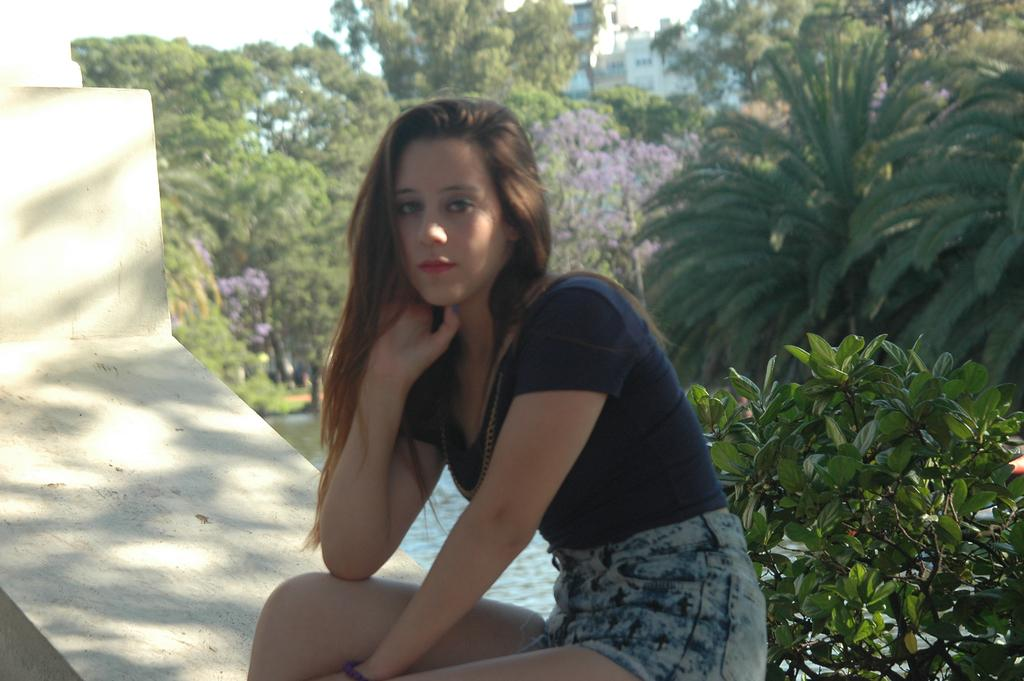What is the woman in the image doing? The woman is sitting on a wall in the image. What can be seen on the right side of the image? There are plants on the right side of the image. What is visible in the image besides the woman and plants? There is water visible in the image. What can be seen in the background of the image? There are trees and buildings in the background of the image. What is the woman writing on the wall in the image? There is no indication that the woman is writing on the wall in the image. Can you see any worms crawling on the plants in the image? There are no worms visible in the image. 